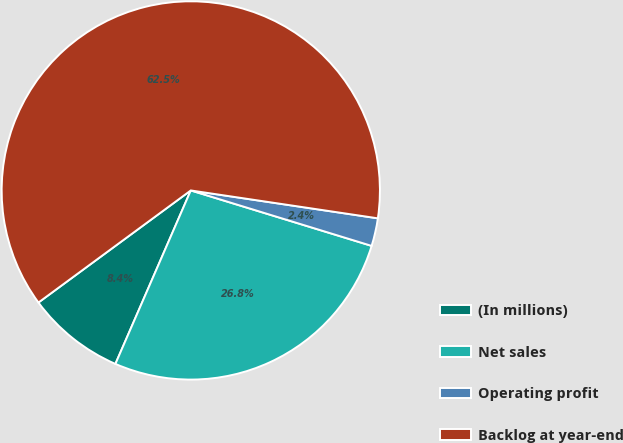Convert chart. <chart><loc_0><loc_0><loc_500><loc_500><pie_chart><fcel>(In millions)<fcel>Net sales<fcel>Operating profit<fcel>Backlog at year-end<nl><fcel>8.38%<fcel>26.79%<fcel>2.38%<fcel>62.45%<nl></chart> 